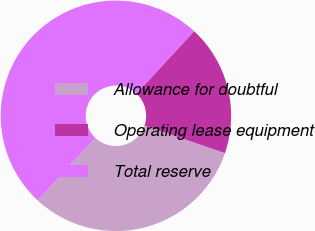Convert chart. <chart><loc_0><loc_0><loc_500><loc_500><pie_chart><fcel>Allowance for doubtful<fcel>Operating lease equipment<fcel>Total reserve<nl><fcel>31.62%<fcel>18.38%<fcel>50.0%<nl></chart> 